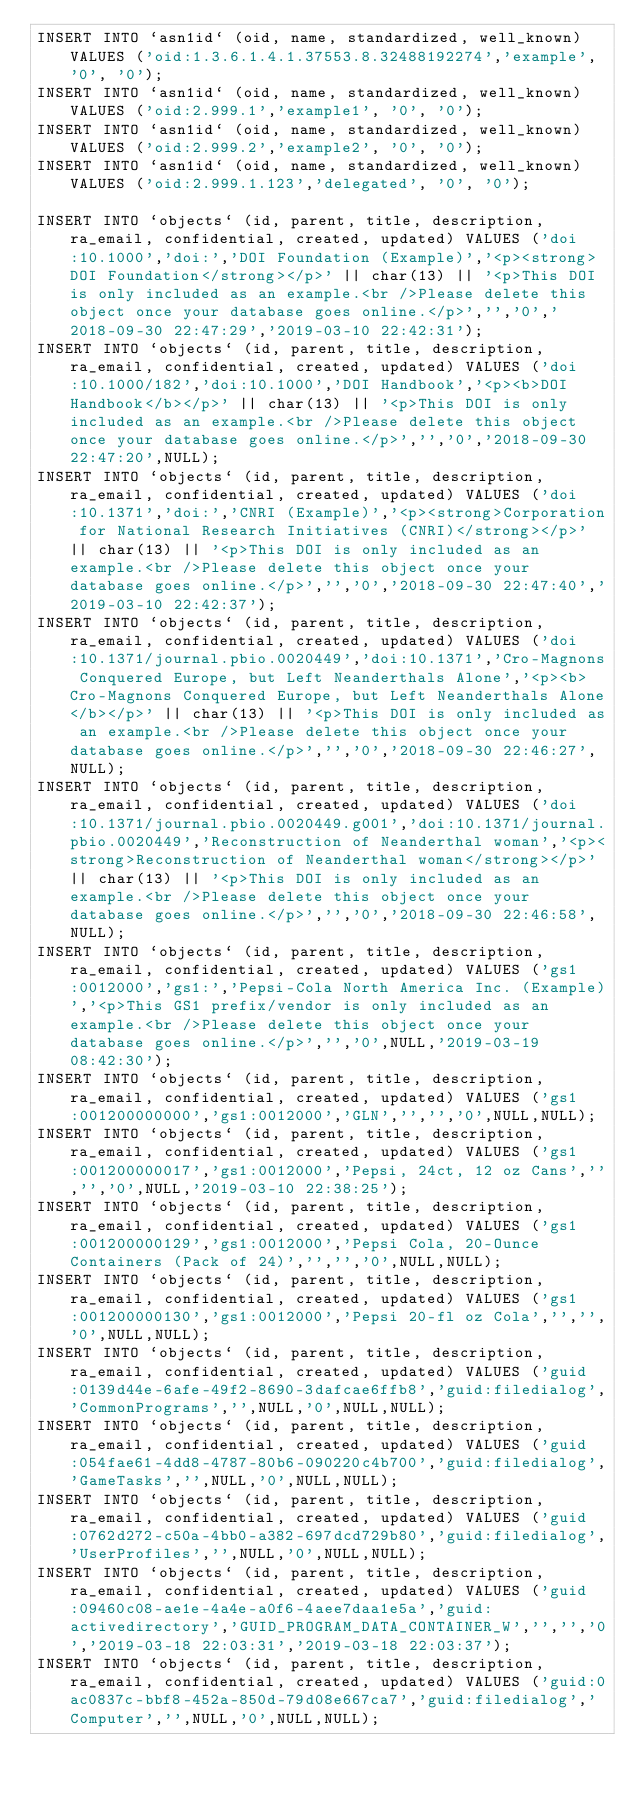Convert code to text. <code><loc_0><loc_0><loc_500><loc_500><_SQL_>INSERT INTO `asn1id` (oid, name, standardized, well_known) VALUES ('oid:1.3.6.1.4.1.37553.8.32488192274','example', '0', '0');
INSERT INTO `asn1id` (oid, name, standardized, well_known) VALUES ('oid:2.999.1','example1', '0', '0');
INSERT INTO `asn1id` (oid, name, standardized, well_known) VALUES ('oid:2.999.2','example2', '0', '0');
INSERT INTO `asn1id` (oid, name, standardized, well_known) VALUES ('oid:2.999.1.123','delegated', '0', '0');

INSERT INTO `objects` (id, parent, title, description, ra_email, confidential, created, updated) VALUES ('doi:10.1000','doi:','DOI Foundation (Example)','<p><strong>DOI Foundation</strong></p>' || char(13) || '<p>This DOI is only included as an example.<br />Please delete this object once your database goes online.</p>','','0','2018-09-30 22:47:29','2019-03-10 22:42:31');
INSERT INTO `objects` (id, parent, title, description, ra_email, confidential, created, updated) VALUES ('doi:10.1000/182','doi:10.1000','DOI Handbook','<p><b>DOI Handbook</b></p>' || char(13) || '<p>This DOI is only included as an example.<br />Please delete this object once your database goes online.</p>','','0','2018-09-30 22:47:20',NULL);
INSERT INTO `objects` (id, parent, title, description, ra_email, confidential, created, updated) VALUES ('doi:10.1371','doi:','CNRI (Example)','<p><strong>Corporation for National Research Initiatives (CNRI)</strong></p>' || char(13) || '<p>This DOI is only included as an example.<br />Please delete this object once your database goes online.</p>','','0','2018-09-30 22:47:40','2019-03-10 22:42:37');
INSERT INTO `objects` (id, parent, title, description, ra_email, confidential, created, updated) VALUES ('doi:10.1371/journal.pbio.0020449','doi:10.1371','Cro-Magnons Conquered Europe, but Left Neanderthals Alone','<p><b>Cro-Magnons Conquered Europe, but Left Neanderthals Alone</b></p>' || char(13) || '<p>This DOI is only included as an example.<br />Please delete this object once your database goes online.</p>','','0','2018-09-30 22:46:27',NULL);
INSERT INTO `objects` (id, parent, title, description, ra_email, confidential, created, updated) VALUES ('doi:10.1371/journal.pbio.0020449.g001','doi:10.1371/journal.pbio.0020449','Reconstruction of Neanderthal woman','<p><strong>Reconstruction of Neanderthal woman</strong></p>' || char(13) || '<p>This DOI is only included as an example.<br />Please delete this object once your database goes online.</p>','','0','2018-09-30 22:46:58',NULL);
INSERT INTO `objects` (id, parent, title, description, ra_email, confidential, created, updated) VALUES ('gs1:0012000','gs1:','Pepsi-Cola North America Inc. (Example)','<p>This GS1 prefix/vendor is only included as an example.<br />Please delete this object once your database goes online.</p>','','0',NULL,'2019-03-19 08:42:30');
INSERT INTO `objects` (id, parent, title, description, ra_email, confidential, created, updated) VALUES ('gs1:001200000000','gs1:0012000','GLN','','','0',NULL,NULL);
INSERT INTO `objects` (id, parent, title, description, ra_email, confidential, created, updated) VALUES ('gs1:001200000017','gs1:0012000','Pepsi, 24ct, 12 oz Cans','','','0',NULL,'2019-03-10 22:38:25');
INSERT INTO `objects` (id, parent, title, description, ra_email, confidential, created, updated) VALUES ('gs1:001200000129','gs1:0012000','Pepsi Cola, 20-Ounce Containers (Pack of 24)','','','0',NULL,NULL);
INSERT INTO `objects` (id, parent, title, description, ra_email, confidential, created, updated) VALUES ('gs1:001200000130','gs1:0012000','Pepsi 20-fl oz Cola','','','0',NULL,NULL);
INSERT INTO `objects` (id, parent, title, description, ra_email, confidential, created, updated) VALUES ('guid:0139d44e-6afe-49f2-8690-3dafcae6ffb8','guid:filedialog','CommonPrograms','',NULL,'0',NULL,NULL);
INSERT INTO `objects` (id, parent, title, description, ra_email, confidential, created, updated) VALUES ('guid:054fae61-4dd8-4787-80b6-090220c4b700','guid:filedialog','GameTasks','',NULL,'0',NULL,NULL);
INSERT INTO `objects` (id, parent, title, description, ra_email, confidential, created, updated) VALUES ('guid:0762d272-c50a-4bb0-a382-697dcd729b80','guid:filedialog','UserProfiles','',NULL,'0',NULL,NULL);
INSERT INTO `objects` (id, parent, title, description, ra_email, confidential, created, updated) VALUES ('guid:09460c08-ae1e-4a4e-a0f6-4aee7daa1e5a','guid:activedirectory','GUID_PROGRAM_DATA_CONTAINER_W','','','0','2019-03-18 22:03:31','2019-03-18 22:03:37');
INSERT INTO `objects` (id, parent, title, description, ra_email, confidential, created, updated) VALUES ('guid:0ac0837c-bbf8-452a-850d-79d08e667ca7','guid:filedialog','Computer','',NULL,'0',NULL,NULL);</code> 